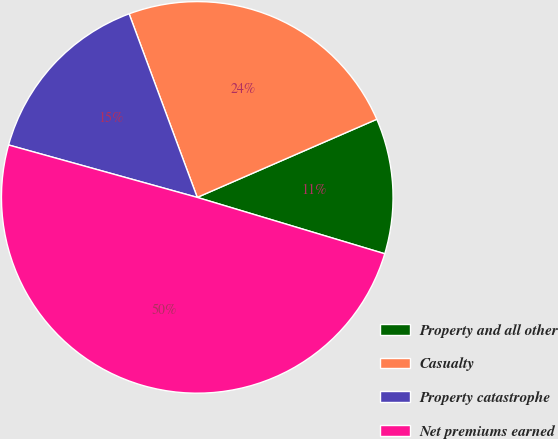<chart> <loc_0><loc_0><loc_500><loc_500><pie_chart><fcel>Property and all other<fcel>Casualty<fcel>Property catastrophe<fcel>Net premiums earned<nl><fcel>11.18%<fcel>24.12%<fcel>15.03%<fcel>49.66%<nl></chart> 